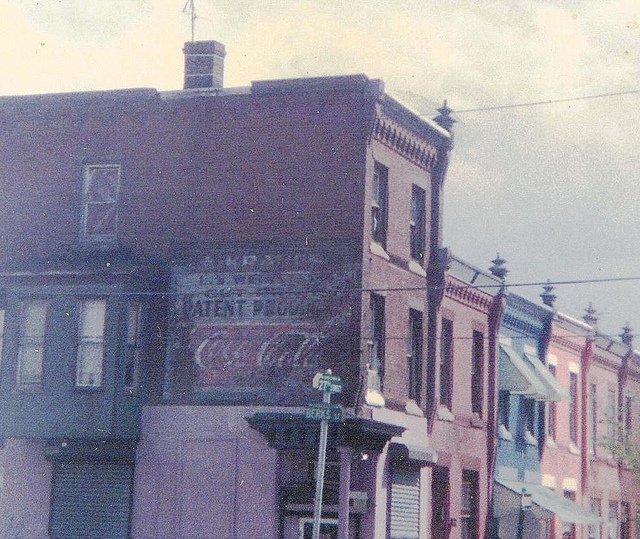Identify and read out the text in this image. Coca Cola 